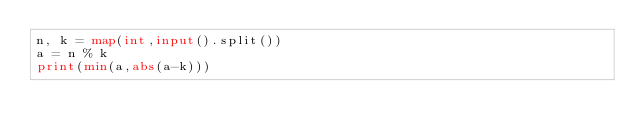<code> <loc_0><loc_0><loc_500><loc_500><_Python_>n, k = map(int,input().split())
a = n % k
print(min(a,abs(a-k)))</code> 